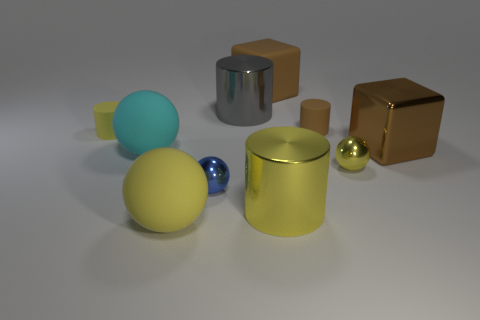Subtract all small brown matte cylinders. How many cylinders are left? 3 Subtract all yellow balls. How many balls are left? 2 Subtract all cylinders. How many objects are left? 6 Subtract 1 cylinders. How many cylinders are left? 3 Subtract all gray blocks. Subtract all purple cylinders. How many blocks are left? 2 Subtract all yellow cubes. How many green spheres are left? 0 Subtract all tiny brown things. Subtract all brown rubber cylinders. How many objects are left? 8 Add 1 tiny matte cylinders. How many tiny matte cylinders are left? 3 Add 9 small yellow shiny spheres. How many small yellow shiny spheres exist? 10 Subtract 0 red cylinders. How many objects are left? 10 